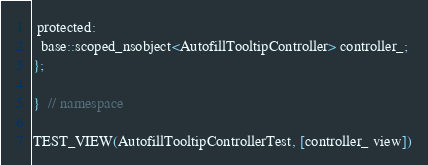Convert code to text. <code><loc_0><loc_0><loc_500><loc_500><_ObjectiveC_>
 protected:
  base::scoped_nsobject<AutofillTooltipController> controller_;
};

}  // namespace

TEST_VIEW(AutofillTooltipControllerTest, [controller_ view])
</code> 